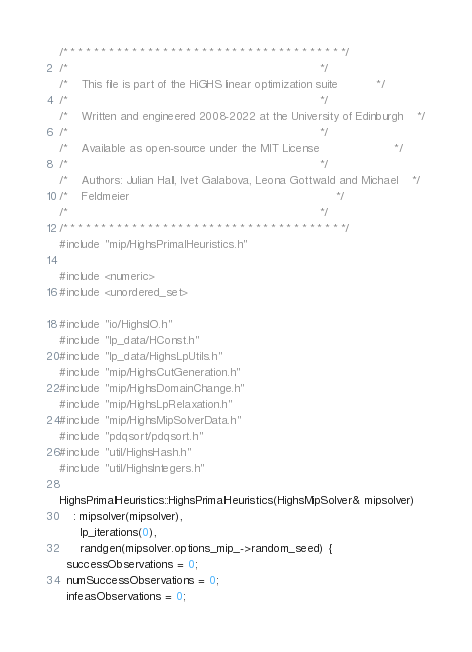<code> <loc_0><loc_0><loc_500><loc_500><_C++_>/* * * * * * * * * * * * * * * * * * * * * * * * * * * * * * * * * * * * */
/*                                                                       */
/*    This file is part of the HiGHS linear optimization suite           */
/*                                                                       */
/*    Written and engineered 2008-2022 at the University of Edinburgh    */
/*                                                                       */
/*    Available as open-source under the MIT License                     */
/*                                                                       */
/*    Authors: Julian Hall, Ivet Galabova, Leona Gottwald and Michael    */
/*    Feldmeier                                                          */
/*                                                                       */
/* * * * * * * * * * * * * * * * * * * * * * * * * * * * * * * * * * * * */
#include "mip/HighsPrimalHeuristics.h"

#include <numeric>
#include <unordered_set>

#include "io/HighsIO.h"
#include "lp_data/HConst.h"
#include "lp_data/HighsLpUtils.h"
#include "mip/HighsCutGeneration.h"
#include "mip/HighsDomainChange.h"
#include "mip/HighsLpRelaxation.h"
#include "mip/HighsMipSolverData.h"
#include "pdqsort/pdqsort.h"
#include "util/HighsHash.h"
#include "util/HighsIntegers.h"

HighsPrimalHeuristics::HighsPrimalHeuristics(HighsMipSolver& mipsolver)
    : mipsolver(mipsolver),
      lp_iterations(0),
      randgen(mipsolver.options_mip_->random_seed) {
  successObservations = 0;
  numSuccessObservations = 0;
  infeasObservations = 0;</code> 